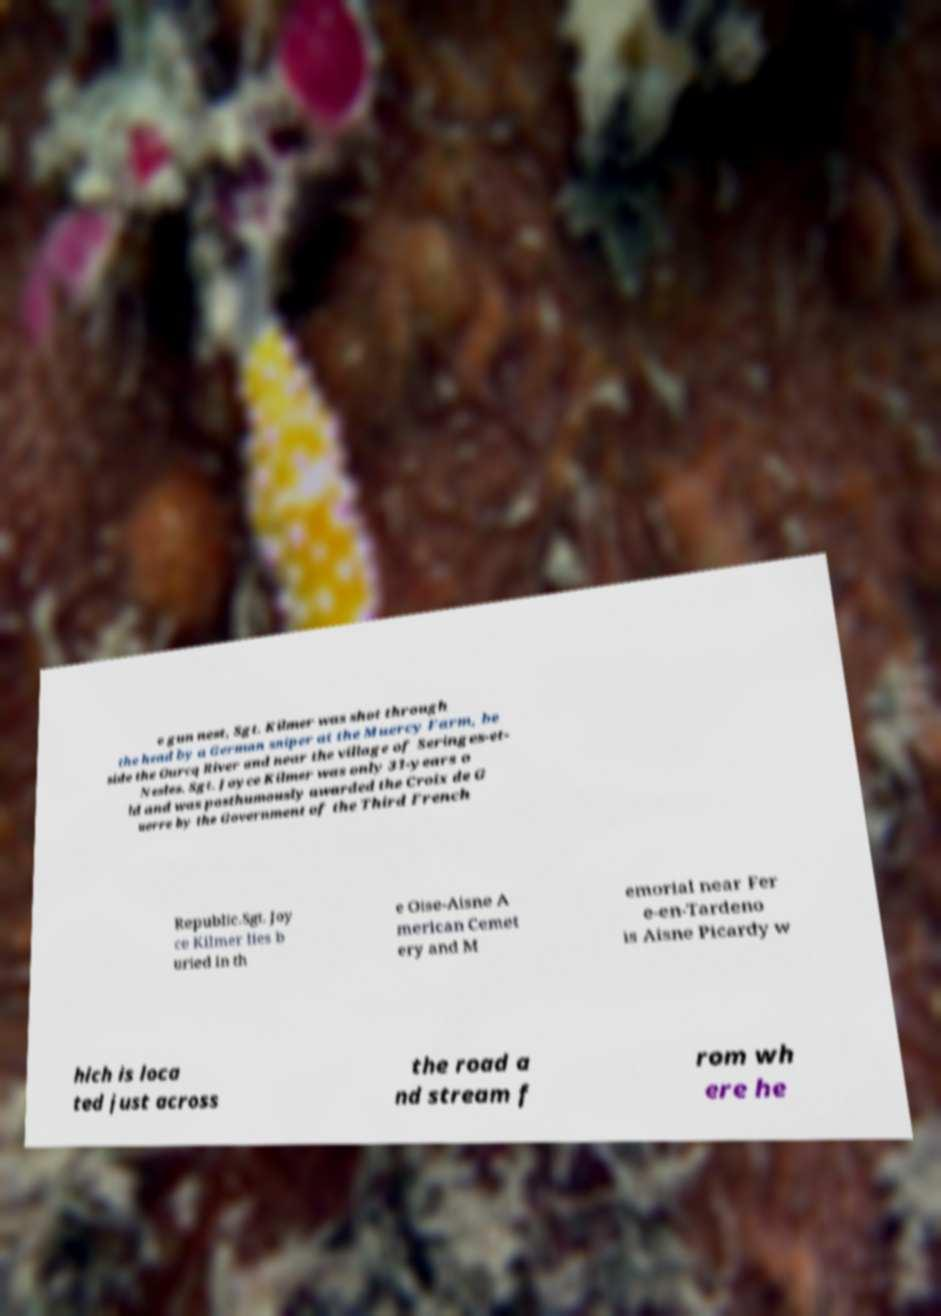There's text embedded in this image that I need extracted. Can you transcribe it verbatim? e gun nest, Sgt. Kilmer was shot through the head by a German sniper at the Muercy Farm, be side the Ourcq River and near the village of Seringes-et- Nesles. Sgt. Joyce Kilmer was only 31-years o ld and was posthumously awarded the Croix de G uerre by the Government of the Third French Republic.Sgt. Joy ce Kilmer lies b uried in th e Oise-Aisne A merican Cemet ery and M emorial near Fer e-en-Tardeno is Aisne Picardy w hich is loca ted just across the road a nd stream f rom wh ere he 